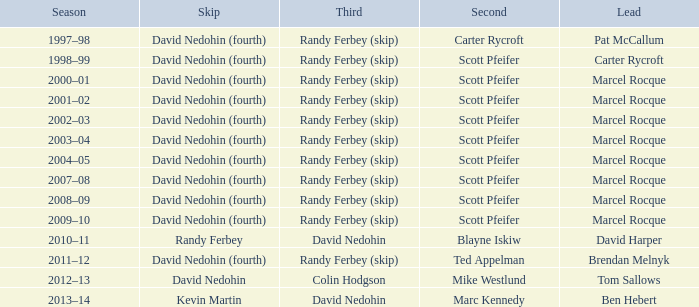Which Season has a Third of colin hodgson? 2012–13. 